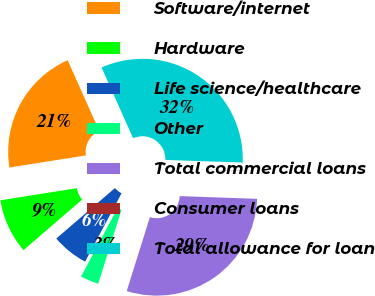Convert chart. <chart><loc_0><loc_0><loc_500><loc_500><pie_chart><fcel>Software/internet<fcel>Hardware<fcel>Life science/healthcare<fcel>Other<fcel>Total commercial loans<fcel>Consumer loans<fcel>Total allowance for loan<nl><fcel>20.82%<fcel>8.82%<fcel>5.89%<fcel>2.96%<fcel>29.28%<fcel>0.03%<fcel>32.21%<nl></chart> 